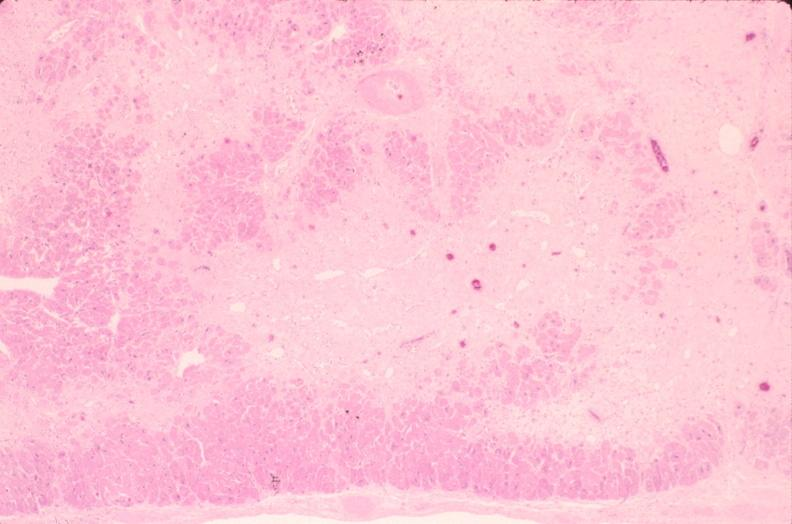what is present?
Answer the question using a single word or phrase. Cardiovascular 